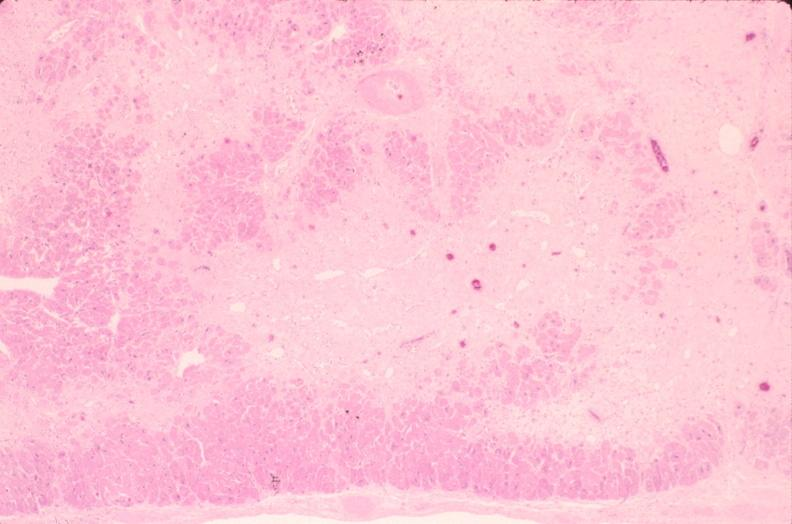what is present?
Answer the question using a single word or phrase. Cardiovascular 